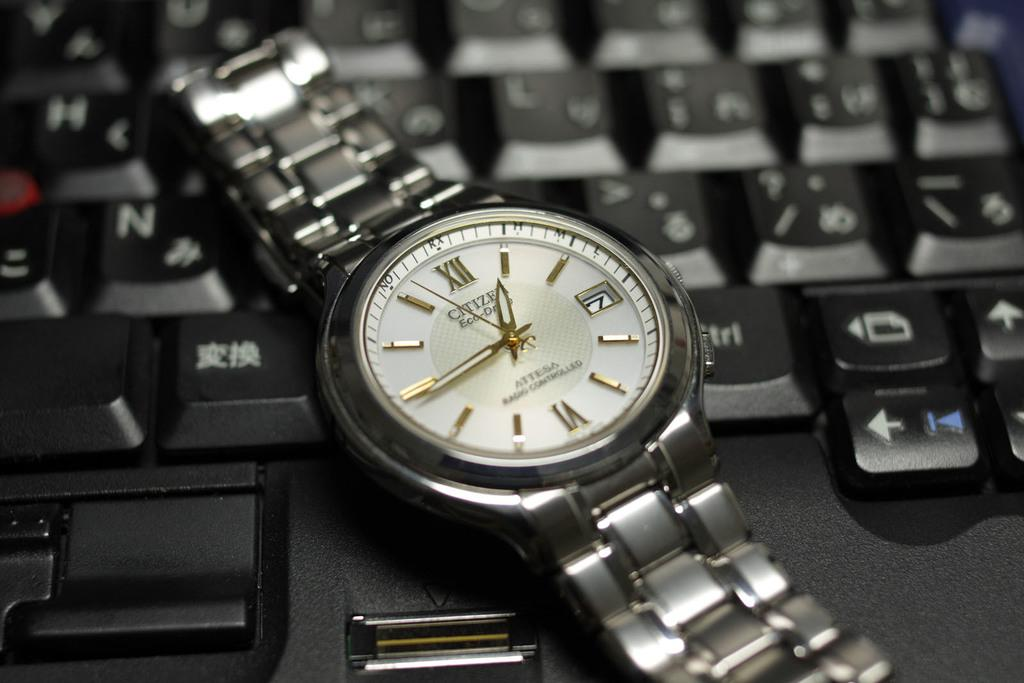<image>
Provide a brief description of the given image. A watch with roman numerals instead of numbers 